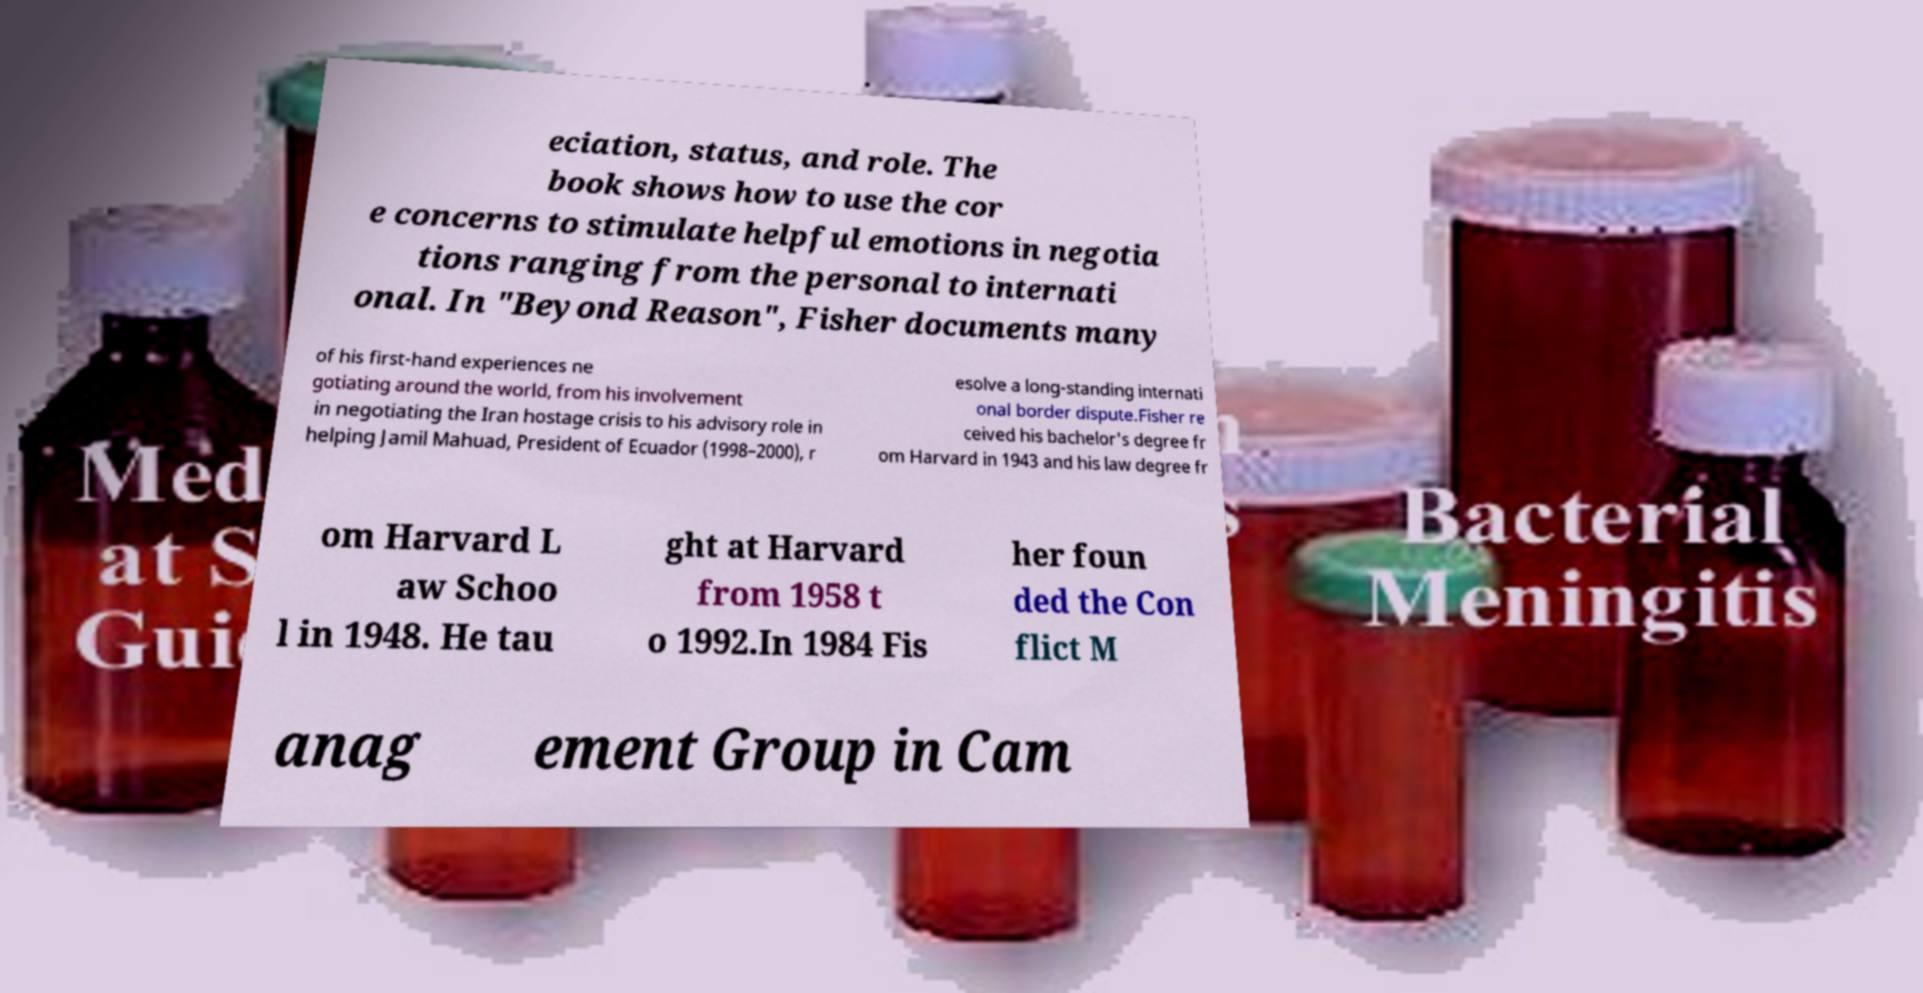Could you extract and type out the text from this image? eciation, status, and role. The book shows how to use the cor e concerns to stimulate helpful emotions in negotia tions ranging from the personal to internati onal. In "Beyond Reason", Fisher documents many of his first-hand experiences ne gotiating around the world, from his involvement in negotiating the Iran hostage crisis to his advisory role in helping Jamil Mahuad, President of Ecuador (1998–2000), r esolve a long-standing internati onal border dispute.Fisher re ceived his bachelor's degree fr om Harvard in 1943 and his law degree fr om Harvard L aw Schoo l in 1948. He tau ght at Harvard from 1958 t o 1992.In 1984 Fis her foun ded the Con flict M anag ement Group in Cam 